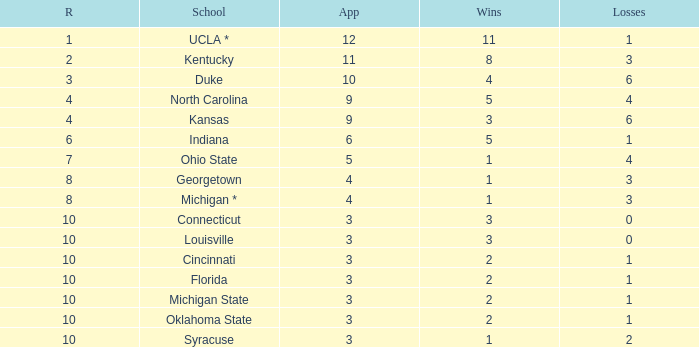Tell me the average Rank for lossess less than 6 and wins less than 11 for michigan state 10.0. 